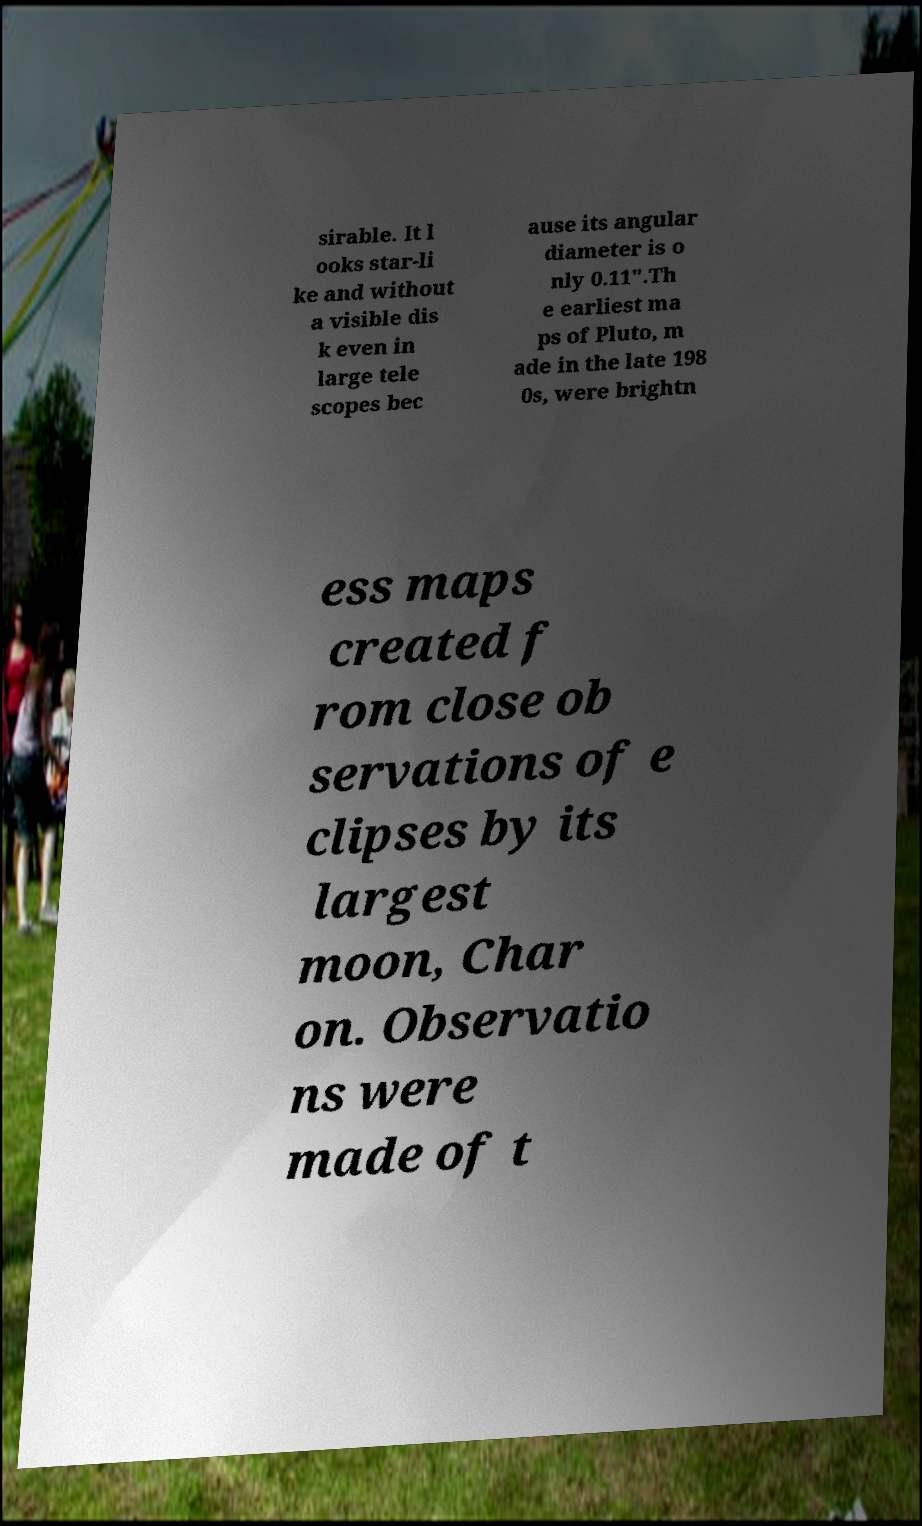Can you read and provide the text displayed in the image?This photo seems to have some interesting text. Can you extract and type it out for me? sirable. It l ooks star-li ke and without a visible dis k even in large tele scopes bec ause its angular diameter is o nly 0.11".Th e earliest ma ps of Pluto, m ade in the late 198 0s, were brightn ess maps created f rom close ob servations of e clipses by its largest moon, Char on. Observatio ns were made of t 